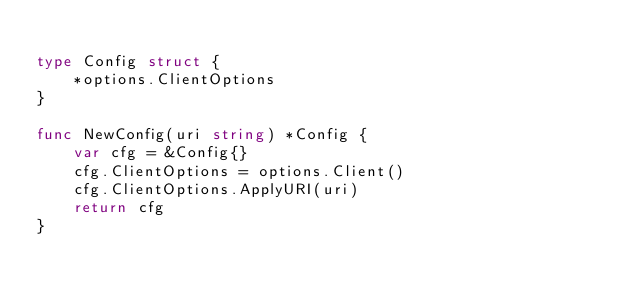<code> <loc_0><loc_0><loc_500><loc_500><_Go_>
type Config struct {
	*options.ClientOptions
}

func NewConfig(uri string) *Config {
	var cfg = &Config{}
	cfg.ClientOptions = options.Client()
	cfg.ClientOptions.ApplyURI(uri)
	return cfg
}
</code> 